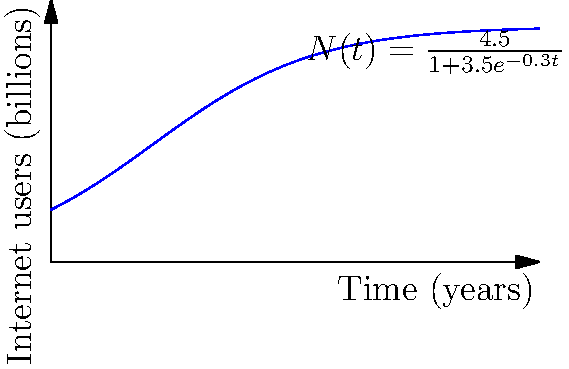Розгляньте логістичну криву, що описує зростання кількості користувачів інтернету в світі. Диференціальне рівняння для цієї кривої має вигляд:

$$\frac{dN}{dt} = kN(1-\frac{N}{K})$$

де $N$ - кількість користувачів, $t$ - час, $k$ - коефіцієнт росту, а $K$ - максимальна кількість користувачів.

Використовуючи графік, визначте максимальну кількість користувачів інтернету ($K$) та початкову кількість користувачів ($N_0$) у мільярдах. Для розв'язання цієї задачі виконаємо наступні кроки:

1) Логістична крива на графіку описується рівнянням:

   $$N(t) = \frac{4.5}{1+3.5e^{-0.3t}}$$

2) Максимальна кількість користувачів ($K$) - це асимптота, до якої прямує крива. З рівняння бачимо, що $K = 4.5$ мільярдів.

3) Щоб знайти початкову кількість користувачів ($N_0$), підставимо $t=0$ у рівняння:

   $$N_0 = N(0) = \frac{4.5}{1+3.5e^{-0.3 \cdot 0}} = \frac{4.5}{1+3.5} = \frac{4.5}{4.5} = 1$$

4) Отже, $N_0 = 1$ мільярд.

Таким чином, максимальна кількість користувачів інтернету ($K$) становить 4.5 мільярдів, а початкова кількість користувачів ($N_0$) - 1 мільярд.
Answer: $K = 4.5$ млрд, $N_0 = 1$ млрд 